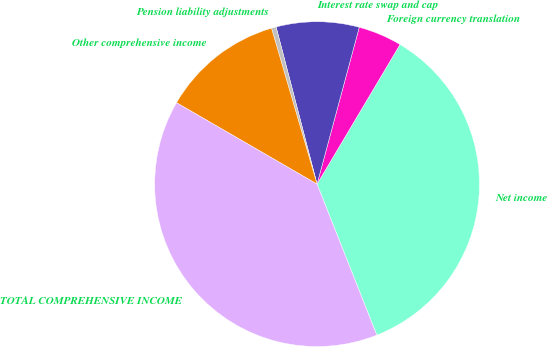Convert chart to OTSL. <chart><loc_0><loc_0><loc_500><loc_500><pie_chart><fcel>Net income<fcel>Foreign currency translation<fcel>Interest rate swap and cap<fcel>Pension liability adjustments<fcel>Other comprehensive income<fcel>TOTAL COMPREHENSIVE INCOME<nl><fcel>35.47%<fcel>4.35%<fcel>8.24%<fcel>0.47%<fcel>12.12%<fcel>39.35%<nl></chart> 